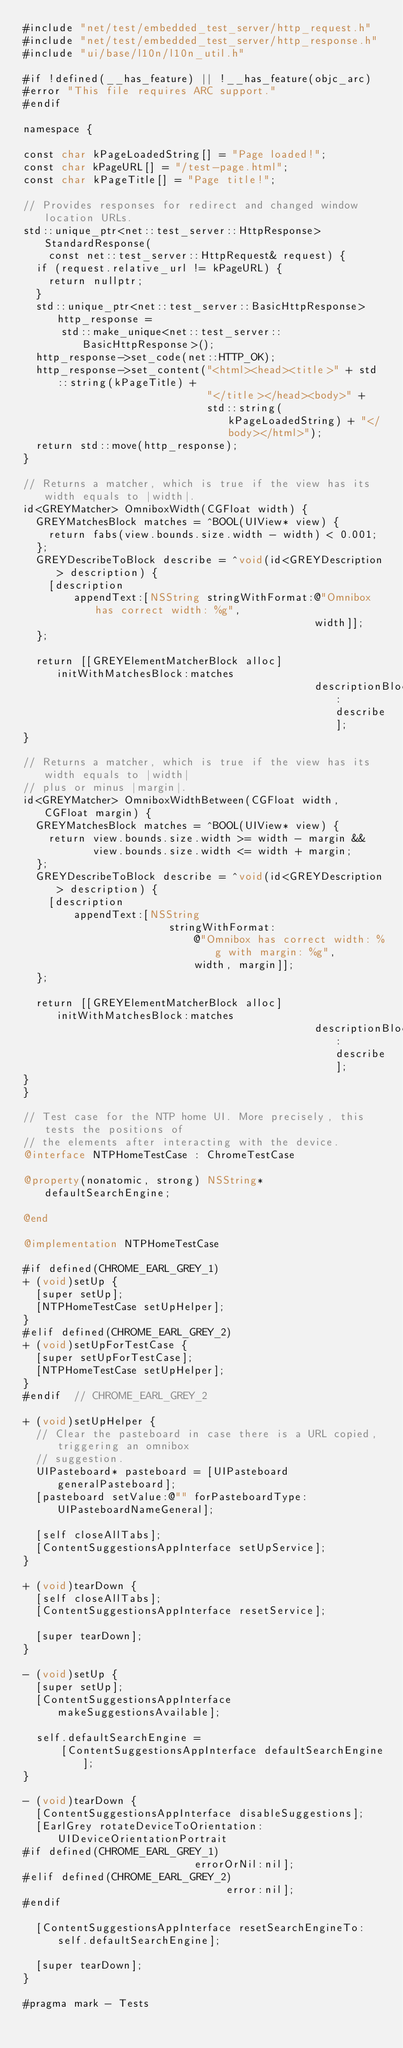Convert code to text. <code><loc_0><loc_0><loc_500><loc_500><_ObjectiveC_>#include "net/test/embedded_test_server/http_request.h"
#include "net/test/embedded_test_server/http_response.h"
#include "ui/base/l10n/l10n_util.h"

#if !defined(__has_feature) || !__has_feature(objc_arc)
#error "This file requires ARC support."
#endif

namespace {

const char kPageLoadedString[] = "Page loaded!";
const char kPageURL[] = "/test-page.html";
const char kPageTitle[] = "Page title!";

// Provides responses for redirect and changed window location URLs.
std::unique_ptr<net::test_server::HttpResponse> StandardResponse(
    const net::test_server::HttpRequest& request) {
  if (request.relative_url != kPageURL) {
    return nullptr;
  }
  std::unique_ptr<net::test_server::BasicHttpResponse> http_response =
      std::make_unique<net::test_server::BasicHttpResponse>();
  http_response->set_code(net::HTTP_OK);
  http_response->set_content("<html><head><title>" + std::string(kPageTitle) +
                             "</title></head><body>" +
                             std::string(kPageLoadedString) + "</body></html>");
  return std::move(http_response);
}

// Returns a matcher, which is true if the view has its width equals to |width|.
id<GREYMatcher> OmniboxWidth(CGFloat width) {
  GREYMatchesBlock matches = ^BOOL(UIView* view) {
    return fabs(view.bounds.size.width - width) < 0.001;
  };
  GREYDescribeToBlock describe = ^void(id<GREYDescription> description) {
    [description
        appendText:[NSString stringWithFormat:@"Omnibox has correct width: %g",
                                              width]];
  };

  return [[GREYElementMatcherBlock alloc] initWithMatchesBlock:matches
                                              descriptionBlock:describe];
}

// Returns a matcher, which is true if the view has its width equals to |width|
// plus or minus |margin|.
id<GREYMatcher> OmniboxWidthBetween(CGFloat width, CGFloat margin) {
  GREYMatchesBlock matches = ^BOOL(UIView* view) {
    return view.bounds.size.width >= width - margin &&
           view.bounds.size.width <= width + margin;
  };
  GREYDescribeToBlock describe = ^void(id<GREYDescription> description) {
    [description
        appendText:[NSString
                       stringWithFormat:
                           @"Omnibox has correct width: %g with margin: %g",
                           width, margin]];
  };

  return [[GREYElementMatcherBlock alloc] initWithMatchesBlock:matches
                                              descriptionBlock:describe];
}
}

// Test case for the NTP home UI. More precisely, this tests the positions of
// the elements after interacting with the device.
@interface NTPHomeTestCase : ChromeTestCase

@property(nonatomic, strong) NSString* defaultSearchEngine;

@end

@implementation NTPHomeTestCase

#if defined(CHROME_EARL_GREY_1)
+ (void)setUp {
  [super setUp];
  [NTPHomeTestCase setUpHelper];
}
#elif defined(CHROME_EARL_GREY_2)
+ (void)setUpForTestCase {
  [super setUpForTestCase];
  [NTPHomeTestCase setUpHelper];
}
#endif  // CHROME_EARL_GREY_2

+ (void)setUpHelper {
  // Clear the pasteboard in case there is a URL copied, triggering an omnibox
  // suggestion.
  UIPasteboard* pasteboard = [UIPasteboard generalPasteboard];
  [pasteboard setValue:@"" forPasteboardType:UIPasteboardNameGeneral];

  [self closeAllTabs];
  [ContentSuggestionsAppInterface setUpService];
}

+ (void)tearDown {
  [self closeAllTabs];
  [ContentSuggestionsAppInterface resetService];

  [super tearDown];
}

- (void)setUp {
  [super setUp];
  [ContentSuggestionsAppInterface makeSuggestionsAvailable];

  self.defaultSearchEngine =
      [ContentSuggestionsAppInterface defaultSearchEngine];
}

- (void)tearDown {
  [ContentSuggestionsAppInterface disableSuggestions];
  [EarlGrey rotateDeviceToOrientation:UIDeviceOrientationPortrait
#if defined(CHROME_EARL_GREY_1)
                           errorOrNil:nil];
#elif defined(CHROME_EARL_GREY_2)
                                error:nil];
#endif

  [ContentSuggestionsAppInterface resetSearchEngineTo:self.defaultSearchEngine];

  [super tearDown];
}

#pragma mark - Tests
</code> 